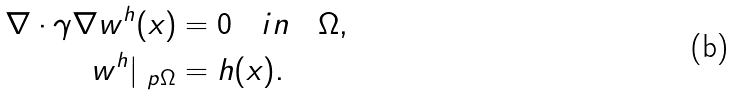Convert formula to latex. <formula><loc_0><loc_0><loc_500><loc_500>\nabla \cdot \gamma \nabla w ^ { h } ( x ) & = 0 \quad i n \quad \Omega , \\ w ^ { h } | _ { \ p \Omega } & = h ( x ) .</formula> 